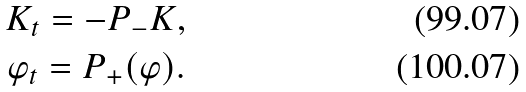<formula> <loc_0><loc_0><loc_500><loc_500>K _ { t } = - P _ { - } K , \\ \varphi _ { t } = P _ { + } ( \varphi ) .</formula> 